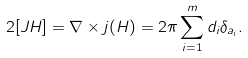Convert formula to latex. <formula><loc_0><loc_0><loc_500><loc_500>2 [ J H ] = \nabla \times j ( H ) = 2 \pi \sum _ { i = 1 } ^ { m } d _ { i } \delta _ { a _ { i } } .</formula> 